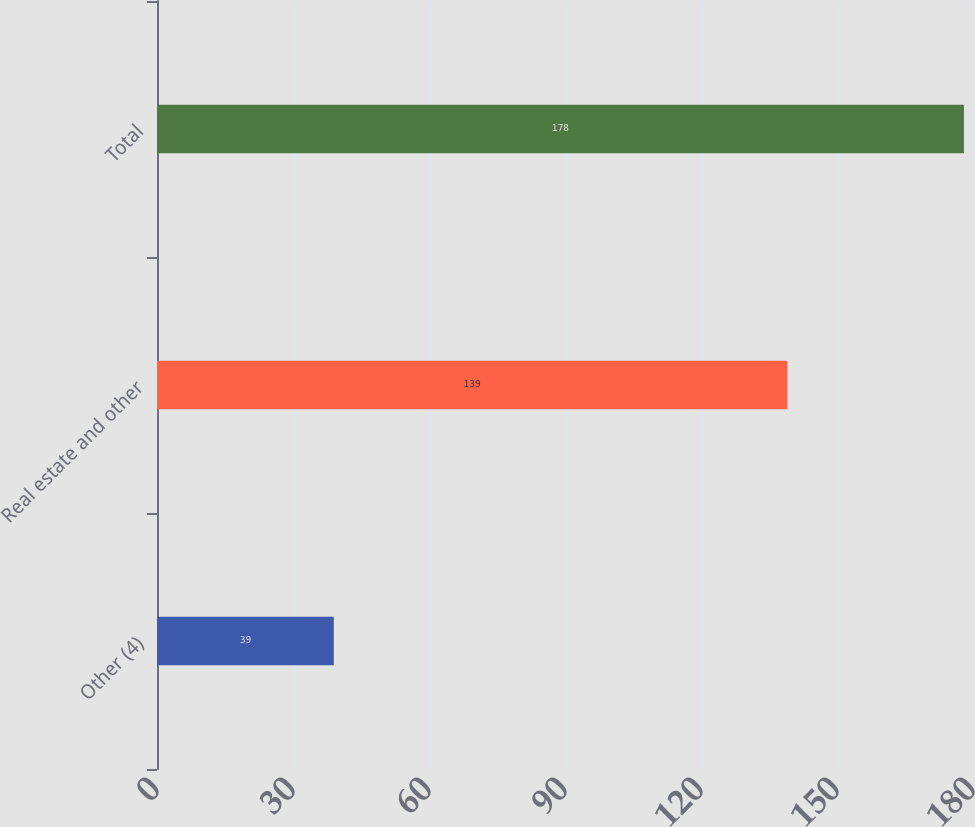Convert chart to OTSL. <chart><loc_0><loc_0><loc_500><loc_500><bar_chart><fcel>Other (4)<fcel>Real estate and other<fcel>Total<nl><fcel>39<fcel>139<fcel>178<nl></chart> 